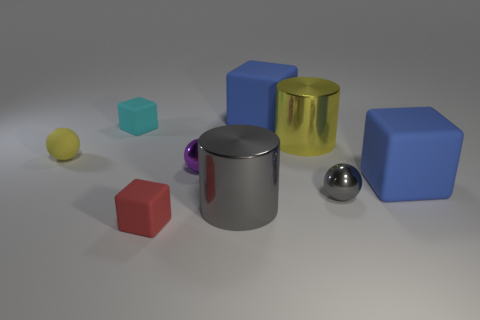Are there any things that have the same material as the gray cylinder?
Keep it short and to the point. Yes. What color is the other small shiny object that is the same shape as the tiny purple object?
Your answer should be very brief. Gray. Does the cyan block have the same material as the big blue block that is in front of the small purple object?
Provide a short and direct response. Yes. There is a big shiny object that is in front of the yellow object that is on the left side of the big gray metallic cylinder; what is its shape?
Your response must be concise. Cylinder. There is a yellow object that is right of the yellow rubber object; does it have the same size as the gray metallic cylinder?
Offer a terse response. Yes. How many other objects are the same shape as the big gray shiny thing?
Give a very brief answer. 1. There is a big metallic object that is behind the purple ball; is it the same color as the rubber ball?
Ensure brevity in your answer.  Yes. Are there any things that have the same color as the tiny matte ball?
Keep it short and to the point. Yes. There is a large yellow cylinder; how many tiny shiny spheres are left of it?
Give a very brief answer. 1. How many other things are the same size as the yellow cylinder?
Ensure brevity in your answer.  3. 